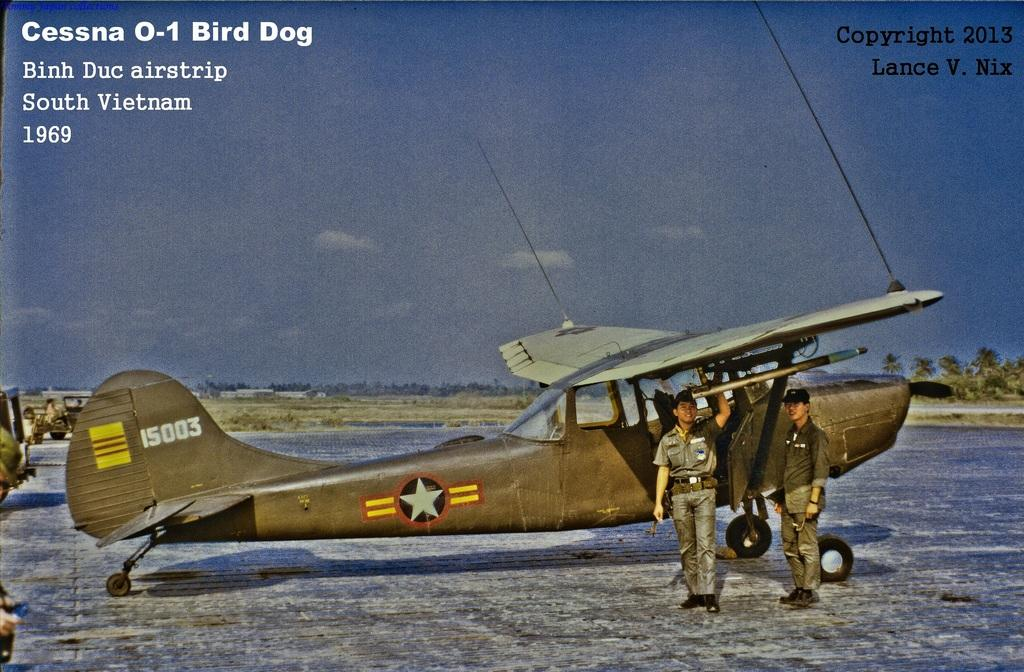<image>
Present a compact description of the photo's key features. An image with an old war airplane and has two military men in front of it with the words Cessna 0-1 Bird Dog on it 